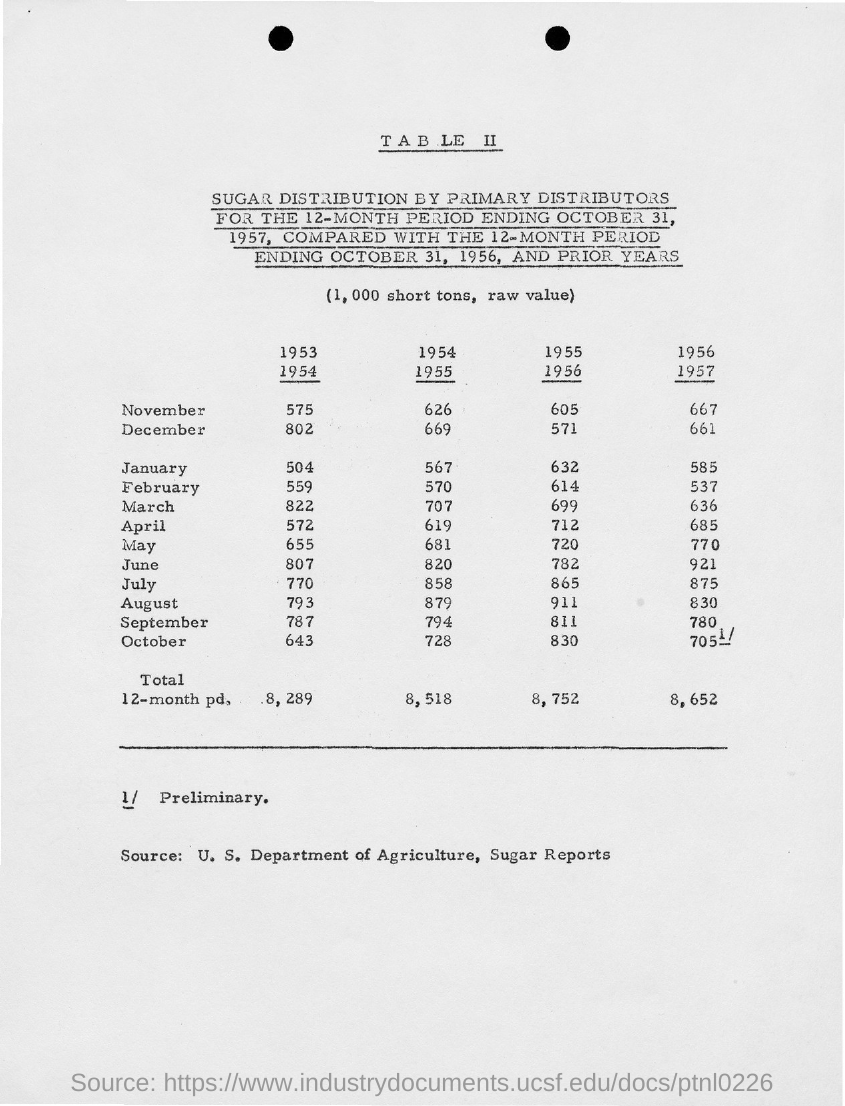What is the Total value for the year 1953-1954?
Your answer should be very brief. 8,289. 